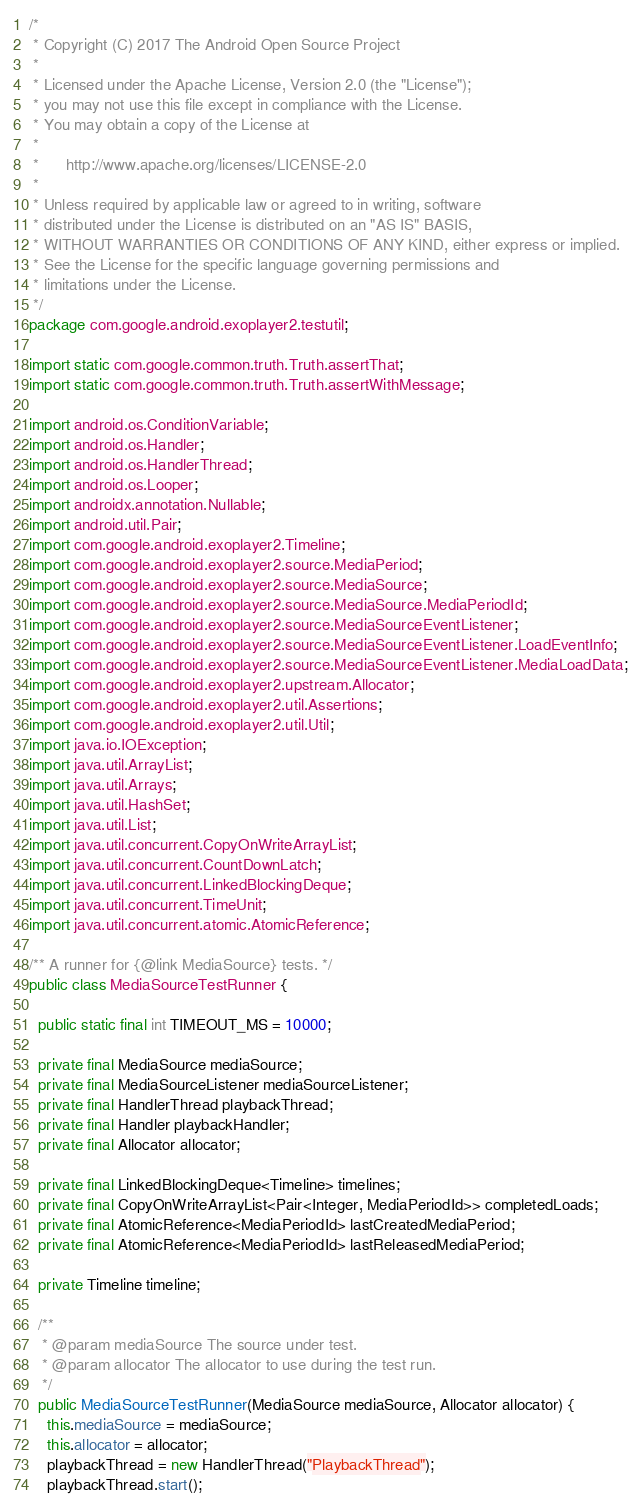Convert code to text. <code><loc_0><loc_0><loc_500><loc_500><_Java_>/*
 * Copyright (C) 2017 The Android Open Source Project
 *
 * Licensed under the Apache License, Version 2.0 (the "License");
 * you may not use this file except in compliance with the License.
 * You may obtain a copy of the License at
 *
 *      http://www.apache.org/licenses/LICENSE-2.0
 *
 * Unless required by applicable law or agreed to in writing, software
 * distributed under the License is distributed on an "AS IS" BASIS,
 * WITHOUT WARRANTIES OR CONDITIONS OF ANY KIND, either express or implied.
 * See the License for the specific language governing permissions and
 * limitations under the License.
 */
package com.google.android.exoplayer2.testutil;

import static com.google.common.truth.Truth.assertThat;
import static com.google.common.truth.Truth.assertWithMessage;

import android.os.ConditionVariable;
import android.os.Handler;
import android.os.HandlerThread;
import android.os.Looper;
import androidx.annotation.Nullable;
import android.util.Pair;
import com.google.android.exoplayer2.Timeline;
import com.google.android.exoplayer2.source.MediaPeriod;
import com.google.android.exoplayer2.source.MediaSource;
import com.google.android.exoplayer2.source.MediaSource.MediaPeriodId;
import com.google.android.exoplayer2.source.MediaSourceEventListener;
import com.google.android.exoplayer2.source.MediaSourceEventListener.LoadEventInfo;
import com.google.android.exoplayer2.source.MediaSourceEventListener.MediaLoadData;
import com.google.android.exoplayer2.upstream.Allocator;
import com.google.android.exoplayer2.util.Assertions;
import com.google.android.exoplayer2.util.Util;
import java.io.IOException;
import java.util.ArrayList;
import java.util.Arrays;
import java.util.HashSet;
import java.util.List;
import java.util.concurrent.CopyOnWriteArrayList;
import java.util.concurrent.CountDownLatch;
import java.util.concurrent.LinkedBlockingDeque;
import java.util.concurrent.TimeUnit;
import java.util.concurrent.atomic.AtomicReference;

/** A runner for {@link MediaSource} tests. */
public class MediaSourceTestRunner {

  public static final int TIMEOUT_MS = 10000;

  private final MediaSource mediaSource;
  private final MediaSourceListener mediaSourceListener;
  private final HandlerThread playbackThread;
  private final Handler playbackHandler;
  private final Allocator allocator;

  private final LinkedBlockingDeque<Timeline> timelines;
  private final CopyOnWriteArrayList<Pair<Integer, MediaPeriodId>> completedLoads;
  private final AtomicReference<MediaPeriodId> lastCreatedMediaPeriod;
  private final AtomicReference<MediaPeriodId> lastReleasedMediaPeriod;

  private Timeline timeline;

  /**
   * @param mediaSource The source under test.
   * @param allocator The allocator to use during the test run.
   */
  public MediaSourceTestRunner(MediaSource mediaSource, Allocator allocator) {
    this.mediaSource = mediaSource;
    this.allocator = allocator;
    playbackThread = new HandlerThread("PlaybackThread");
    playbackThread.start();</code> 